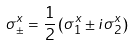<formula> <loc_0><loc_0><loc_500><loc_500>\sigma ^ { x } _ { \pm } = \frac { 1 } { 2 } \left ( \sigma ^ { x } _ { 1 } \pm i \sigma _ { 2 } ^ { x } \right )</formula> 